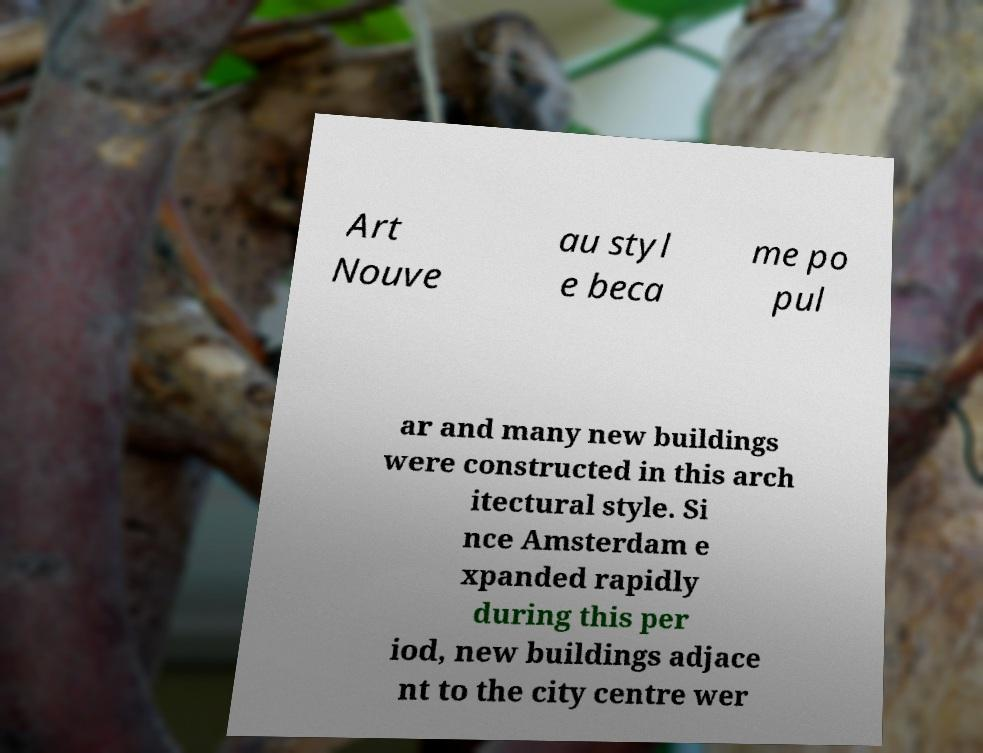Can you read and provide the text displayed in the image?This photo seems to have some interesting text. Can you extract and type it out for me? Art Nouve au styl e beca me po pul ar and many new buildings were constructed in this arch itectural style. Si nce Amsterdam e xpanded rapidly during this per iod, new buildings adjace nt to the city centre wer 